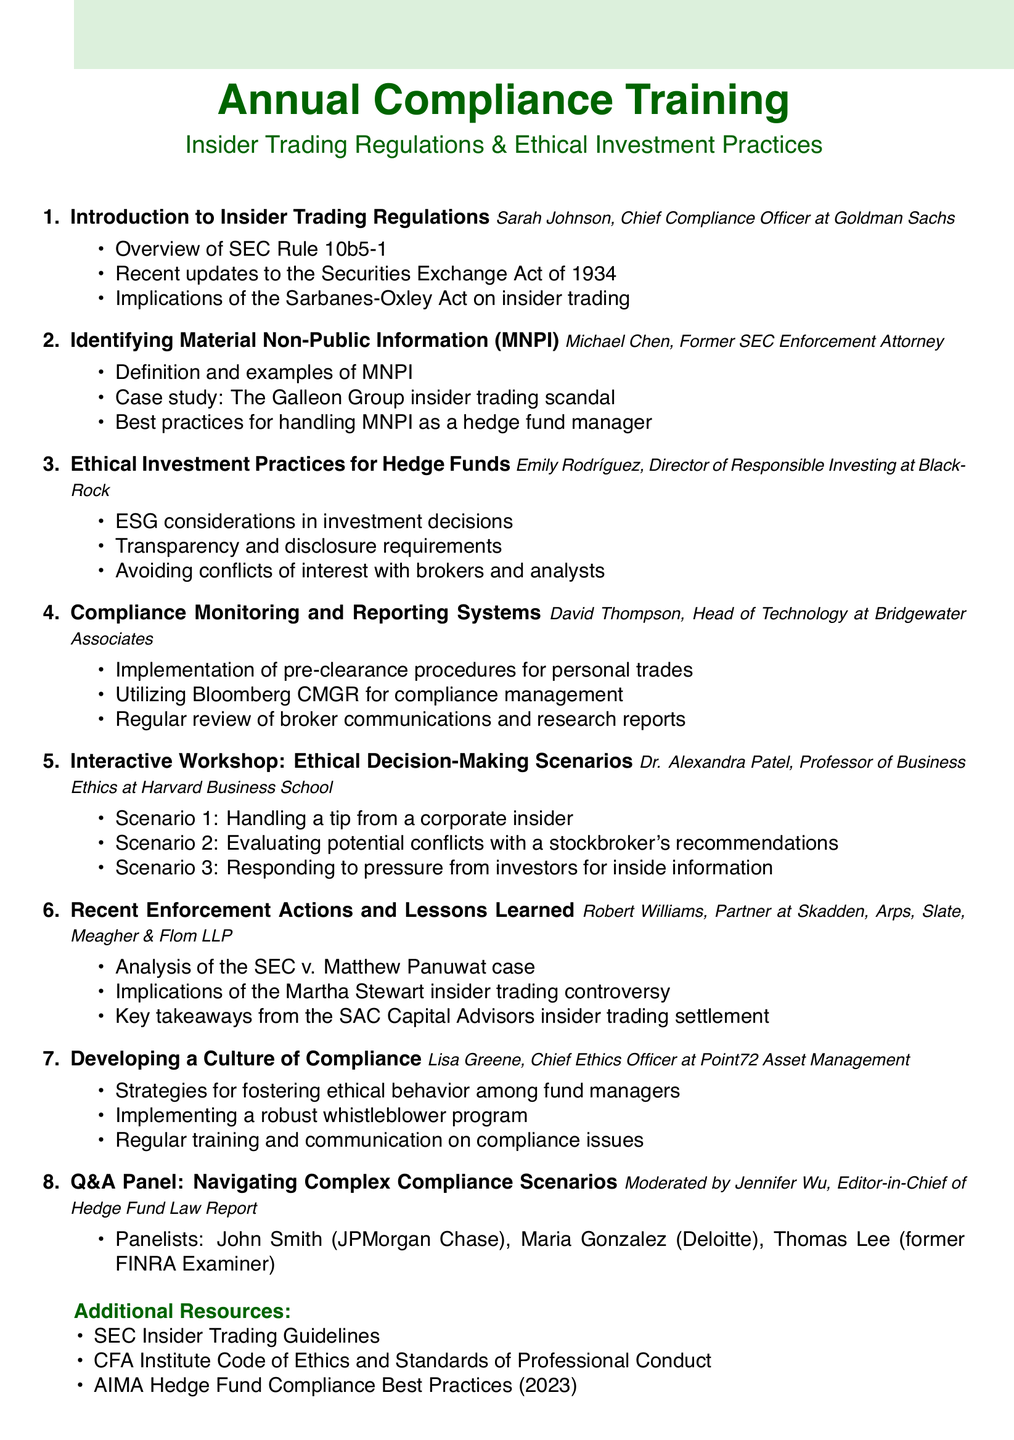What is the title of the first agenda item? The title of the first agenda item is what is presented at the beginning of the agenda, which is "Introduction to Insider Trading Regulations."
Answer: Introduction to Insider Trading Regulations Who is the speaker for the session on "Identifying Material Non-Public Information (MNPI)"? The speaker is specifically mentioned under the agenda item, and for this session, it is "Michael Chen, Former SEC Enforcement Attorney."
Answer: Michael Chen, Former SEC Enforcement Attorney How many speakers are listed in the agenda? The total number of speakers is determined by counting each individual named in the agenda items. There are 7 unique speakers listed.
Answer: 7 What is the main focus of Emily Rodríguez's session? The focus of Emily Rodríguez's session is described in the title and bullet points, highlighting "Ethical Investment Practices for Hedge Funds."
Answer: Ethical Investment Practices for Hedge Funds Which case is analyzed in the "Recent Enforcement Actions and Lessons Learned" section? The case mentioned in this section is specifically stated as "SEC v. Matthew Panuwat."
Answer: SEC v. Matthew Panuwat What is the role of Jennifer Wu in the document? Jennifer Wu is indicated as the moderator for the Q&A panel, which is a unique role for engaging with the audience and other panelists.
Answer: Moderator What type of scenarios are discussed in the interactive workshop? The workshop involves scenarios related to ethics and decision-making, indicated by the title "Interactive Workshop: Ethical Decision-Making Scenarios."
Answer: Ethical Decision-Making Scenarios 